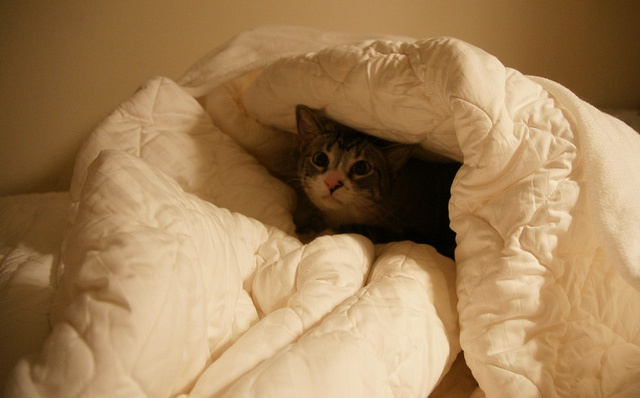Describe the objects in this image and their specific colors. I can see bed in black, tan, and olive tones and cat in black, maroon, and brown tones in this image. 